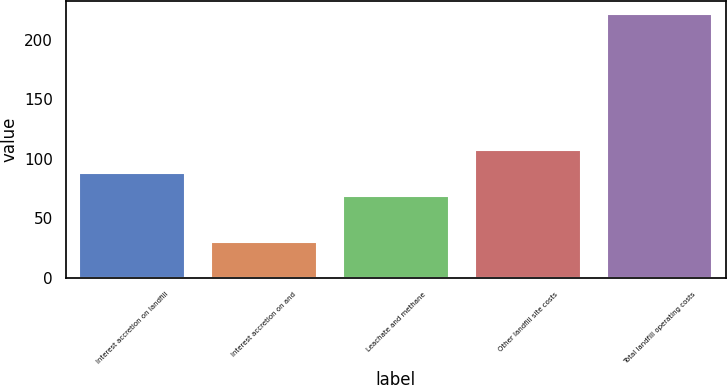Convert chart. <chart><loc_0><loc_0><loc_500><loc_500><bar_chart><fcel>Interest accretion on landfill<fcel>Interest accretion on and<fcel>Leachate and methane<fcel>Other landfill site costs<fcel>Total landfill operating costs<nl><fcel>88.2<fcel>30<fcel>69<fcel>107.4<fcel>222<nl></chart> 